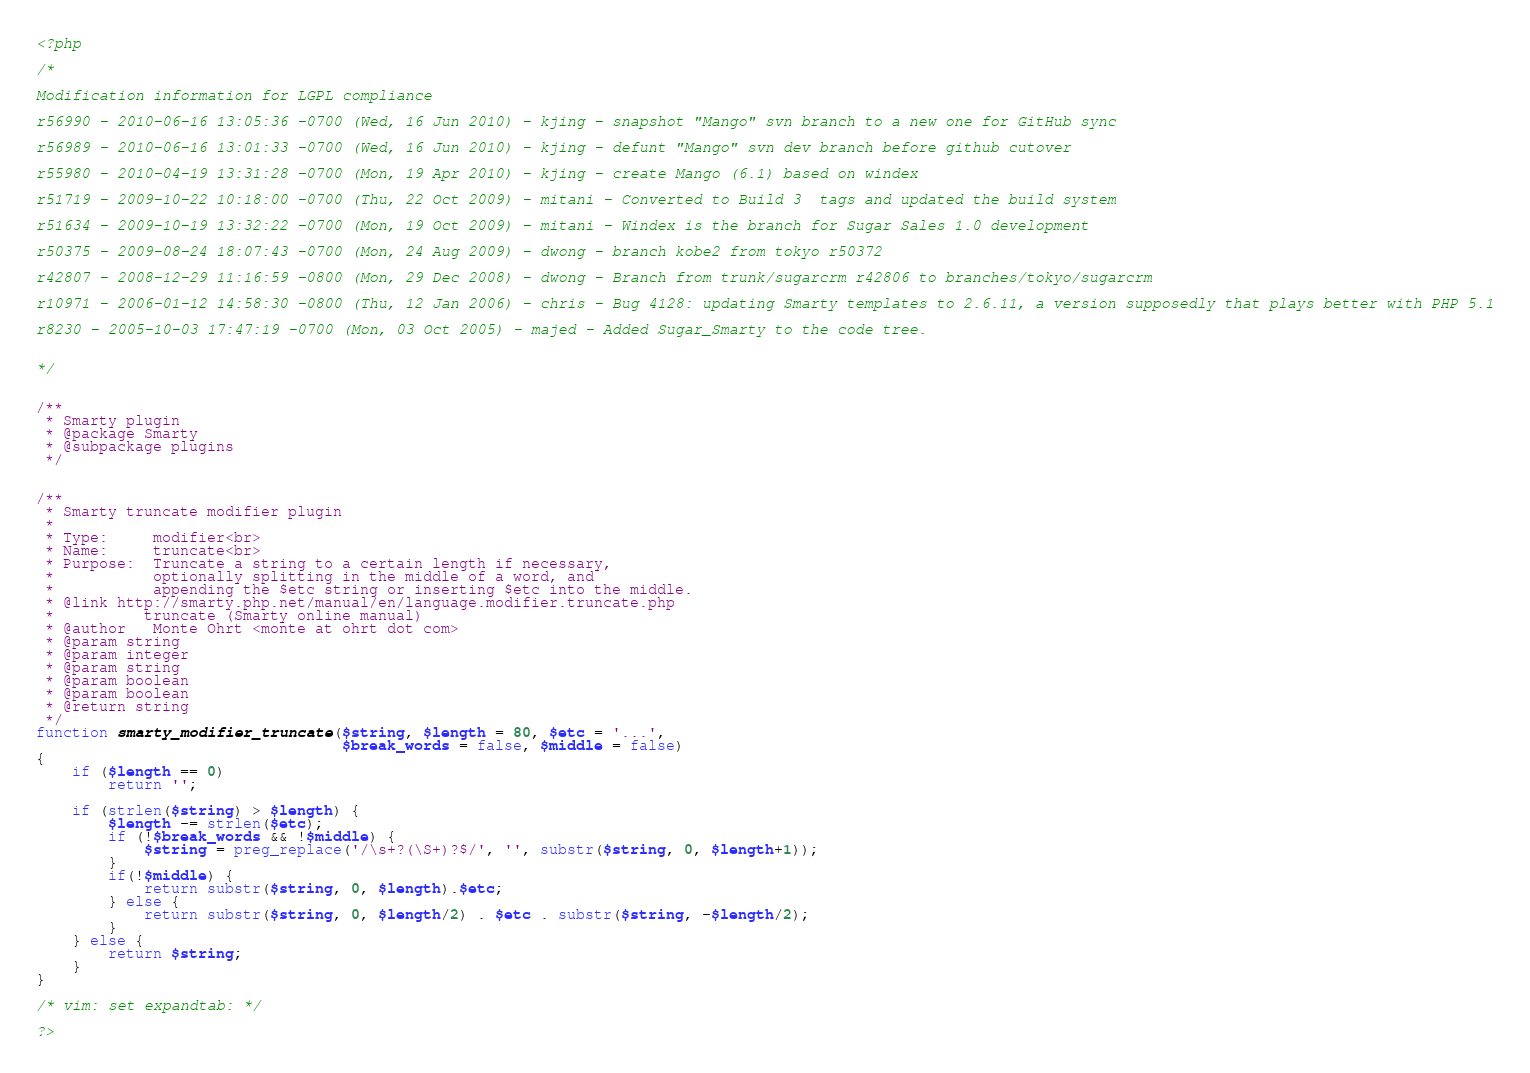Convert code to text. <code><loc_0><loc_0><loc_500><loc_500><_PHP_><?php

/*

Modification information for LGPL compliance

r56990 - 2010-06-16 13:05:36 -0700 (Wed, 16 Jun 2010) - kjing - snapshot "Mango" svn branch to a new one for GitHub sync

r56989 - 2010-06-16 13:01:33 -0700 (Wed, 16 Jun 2010) - kjing - defunt "Mango" svn dev branch before github cutover

r55980 - 2010-04-19 13:31:28 -0700 (Mon, 19 Apr 2010) - kjing - create Mango (6.1) based on windex

r51719 - 2009-10-22 10:18:00 -0700 (Thu, 22 Oct 2009) - mitani - Converted to Build 3  tags and updated the build system 

r51634 - 2009-10-19 13:32:22 -0700 (Mon, 19 Oct 2009) - mitani - Windex is the branch for Sugar Sales 1.0 development

r50375 - 2009-08-24 18:07:43 -0700 (Mon, 24 Aug 2009) - dwong - branch kobe2 from tokyo r50372

r42807 - 2008-12-29 11:16:59 -0800 (Mon, 29 Dec 2008) - dwong - Branch from trunk/sugarcrm r42806 to branches/tokyo/sugarcrm

r10971 - 2006-01-12 14:58:30 -0800 (Thu, 12 Jan 2006) - chris - Bug 4128: updating Smarty templates to 2.6.11, a version supposedly that plays better with PHP 5.1

r8230 - 2005-10-03 17:47:19 -0700 (Mon, 03 Oct 2005) - majed - Added Sugar_Smarty to the code tree.


*/


/**
 * Smarty plugin
 * @package Smarty
 * @subpackage plugins
 */


/**
 * Smarty truncate modifier plugin
 *
 * Type:     modifier<br>
 * Name:     truncate<br>
 * Purpose:  Truncate a string to a certain length if necessary,
 *           optionally splitting in the middle of a word, and
 *           appending the $etc string or inserting $etc into the middle.
 * @link http://smarty.php.net/manual/en/language.modifier.truncate.php
 *          truncate (Smarty online manual)
 * @author   Monte Ohrt <monte at ohrt dot com>
 * @param string
 * @param integer
 * @param string
 * @param boolean
 * @param boolean
 * @return string
 */
function smarty_modifier_truncate($string, $length = 80, $etc = '...',
                                  $break_words = false, $middle = false)
{
    if ($length == 0)
        return '';

    if (strlen($string) > $length) {
        $length -= strlen($etc);
        if (!$break_words && !$middle) {
            $string = preg_replace('/\s+?(\S+)?$/', '', substr($string, 0, $length+1));
        }
        if(!$middle) {
            return substr($string, 0, $length).$etc;
        } else {
            return substr($string, 0, $length/2) . $etc . substr($string, -$length/2);
        }
    } else {
        return $string;
    }
}

/* vim: set expandtab: */

?>
</code> 